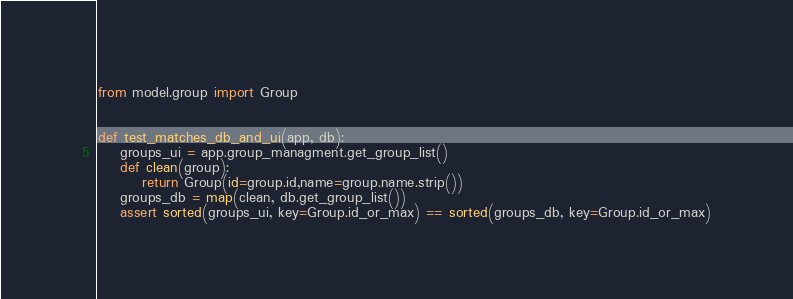<code> <loc_0><loc_0><loc_500><loc_500><_Python_>from model.group import Group


def test_matches_db_and_ui(app, db):
    groups_ui = app.group_managment.get_group_list()
    def clean(group):
        return Group(id=group.id,name=group.name.strip())
    groups_db = map(clean, db.get_group_list())
    assert sorted(groups_ui, key=Group.id_or_max) == sorted(groups_db, key=Group.id_or_max)</code> 